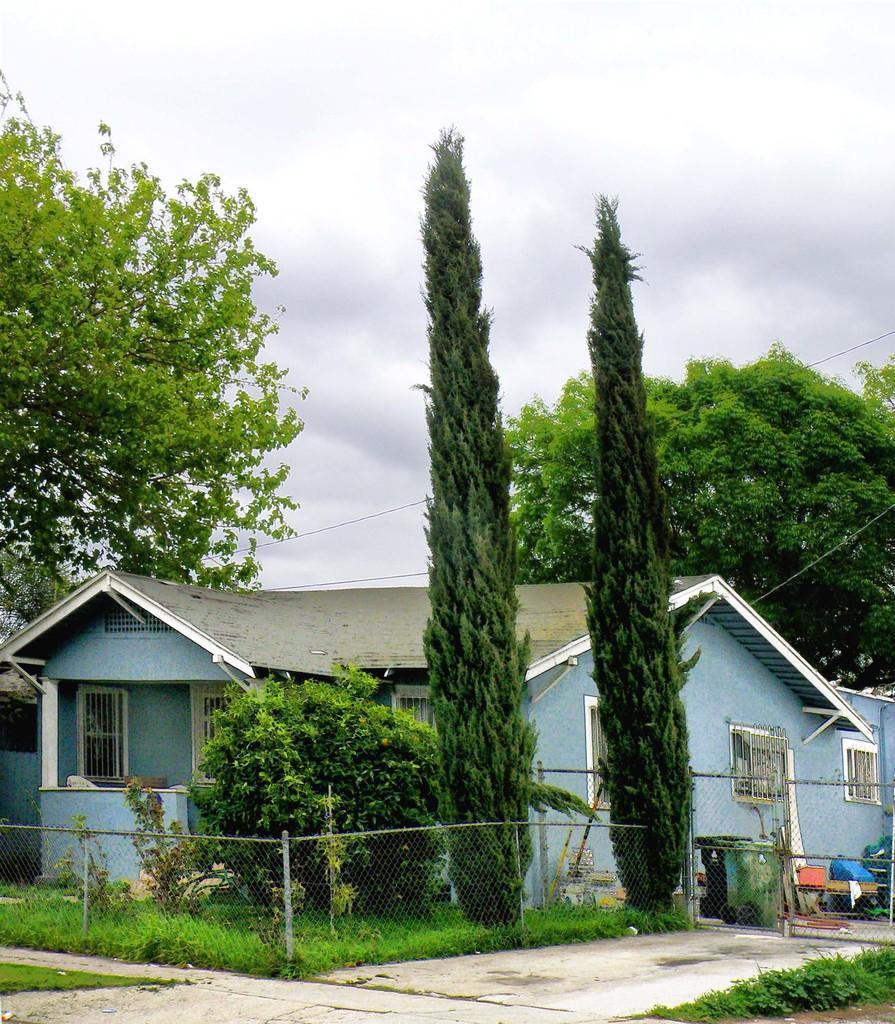Please provide a concise description of this image. In the image we can see there are tall trees and there are houses. There are household items kept outside on the ground. The ground is covered with grass and there is an iron fencing. 